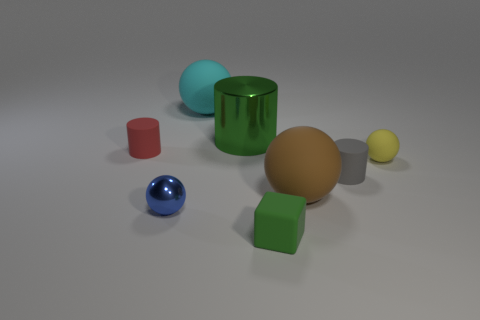There is a large thing that is the same color as the small cube; what is its material?
Provide a succinct answer. Metal. There is a small cylinder that is on the right side of the big brown object; does it have the same color as the big cylinder?
Provide a short and direct response. No. How many objects are balls right of the small shiny thing or big cyan blocks?
Offer a terse response. 3. Are there more cylinders that are left of the tiny blue sphere than yellow spheres that are behind the red cylinder?
Offer a very short reply. Yes. Are the large cyan thing and the tiny blue object made of the same material?
Keep it short and to the point. No. What shape is the thing that is both to the left of the large cyan ball and behind the tiny blue object?
Provide a short and direct response. Cylinder. What is the shape of the big brown object that is the same material as the green block?
Provide a succinct answer. Sphere. Is there a tiny cyan metal cube?
Offer a very short reply. No. Is there a big rubber object right of the small matte cylinder that is to the right of the green cube?
Provide a succinct answer. No. There is a yellow object that is the same shape as the blue object; what is it made of?
Your answer should be very brief. Rubber. 